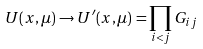Convert formula to latex. <formula><loc_0><loc_0><loc_500><loc_500>U ( x , \mu ) \rightarrow U ^ { \prime } ( x , \mu ) = \prod _ { i < j } G _ { i j }</formula> 